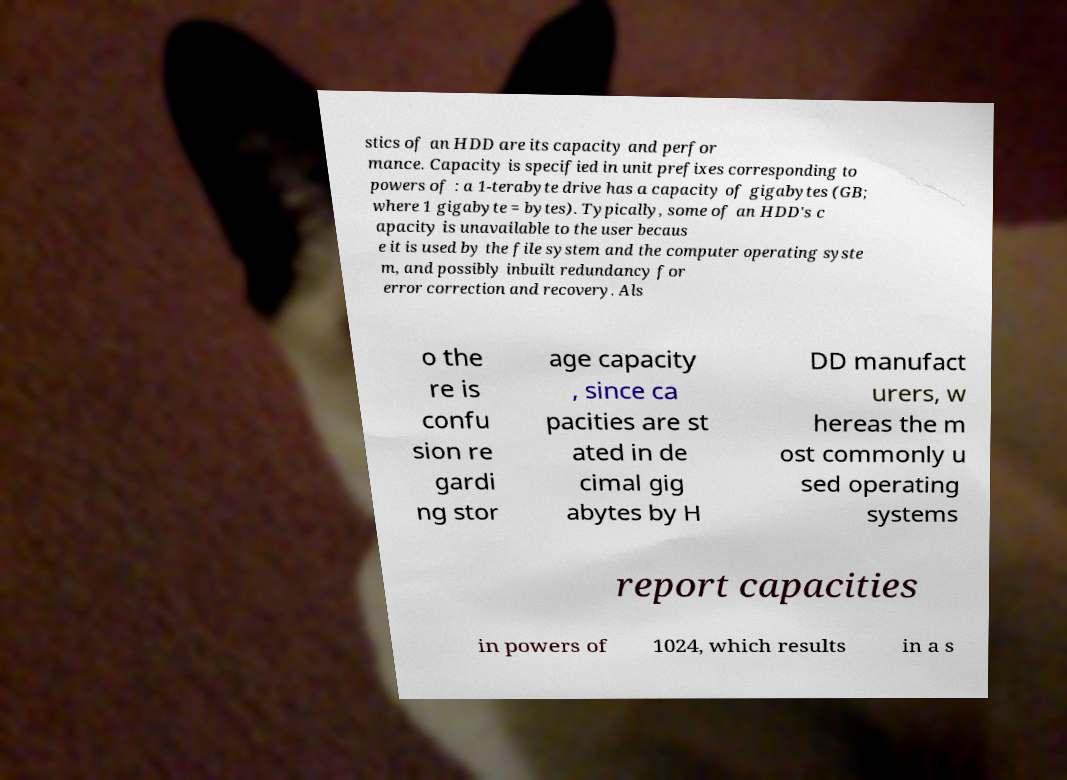Please read and relay the text visible in this image. What does it say? stics of an HDD are its capacity and perfor mance. Capacity is specified in unit prefixes corresponding to powers of : a 1-terabyte drive has a capacity of gigabytes (GB; where 1 gigabyte = bytes). Typically, some of an HDD's c apacity is unavailable to the user becaus e it is used by the file system and the computer operating syste m, and possibly inbuilt redundancy for error correction and recovery. Als o the re is confu sion re gardi ng stor age capacity , since ca pacities are st ated in de cimal gig abytes by H DD manufact urers, w hereas the m ost commonly u sed operating systems report capacities in powers of 1024, which results in a s 